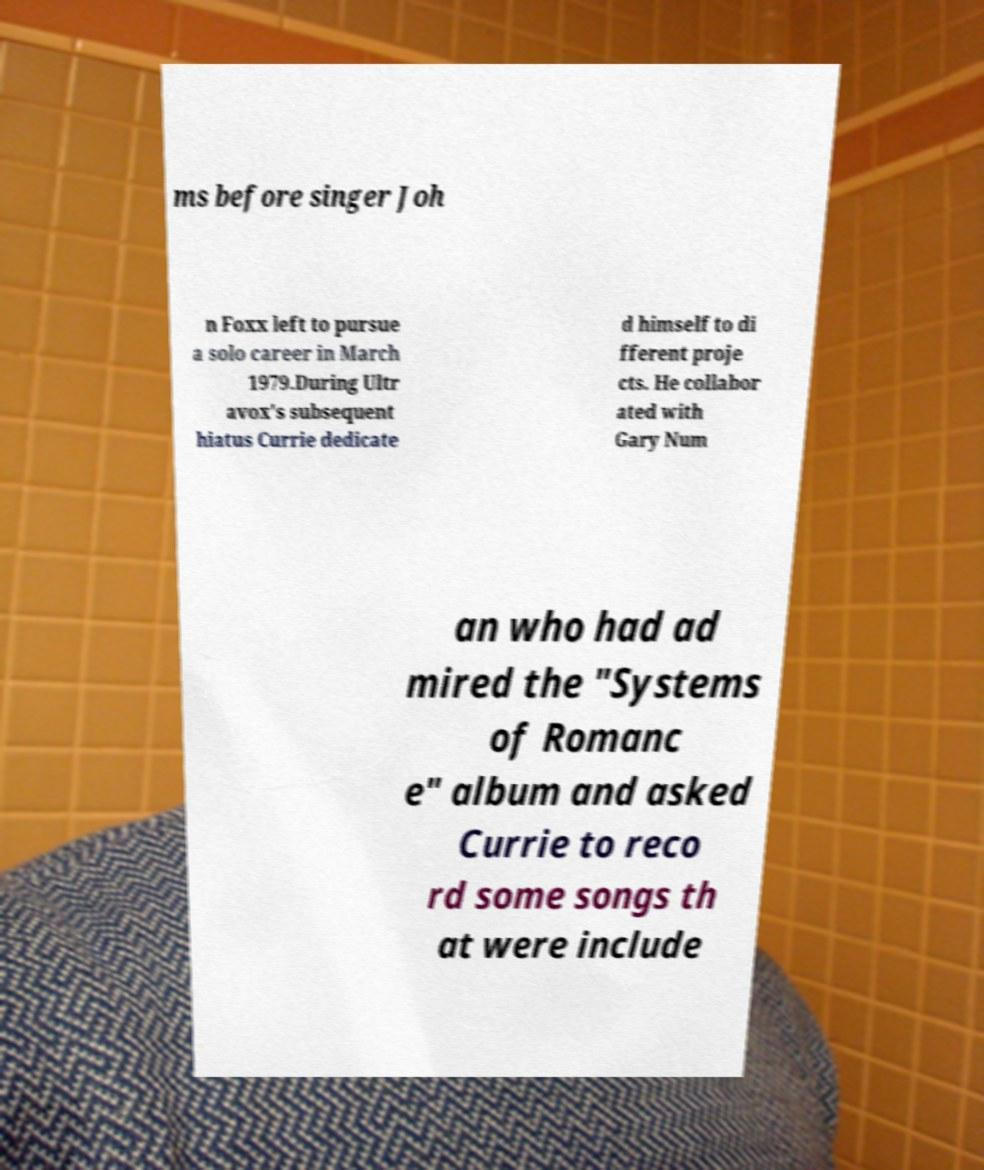Can you accurately transcribe the text from the provided image for me? ms before singer Joh n Foxx left to pursue a solo career in March 1979.During Ultr avox's subsequent hiatus Currie dedicate d himself to di fferent proje cts. He collabor ated with Gary Num an who had ad mired the "Systems of Romanc e" album and asked Currie to reco rd some songs th at were include 